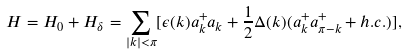<formula> <loc_0><loc_0><loc_500><loc_500>H = H _ { 0 } + H _ { \delta } = \sum _ { | k | < \pi } [ \epsilon ( k ) a ^ { + } _ { k } a _ { k } + \frac { 1 } { 2 } \Delta ( k ) ( a ^ { + } _ { k } a ^ { + } _ { \pi - k } + h . c . ) ] ,</formula> 